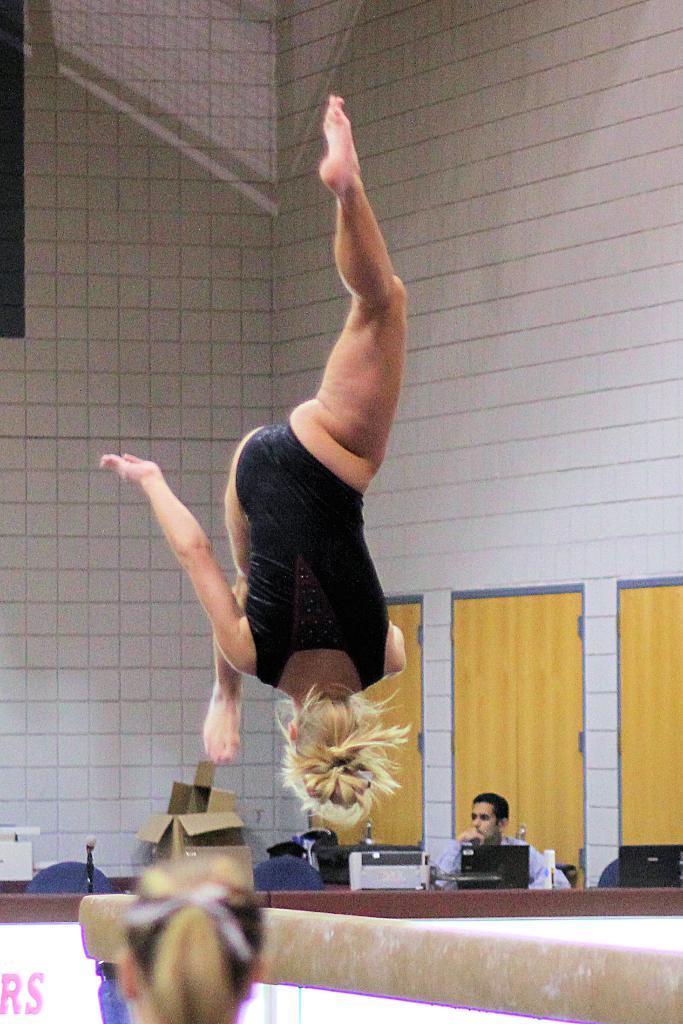Can you describe this image briefly? In the image there is a person jumping upside down in the air, this seems to be gymnastics, in the back there is a man sitting in front of desktop. 